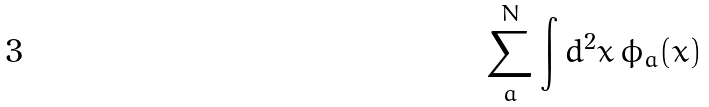Convert formula to latex. <formula><loc_0><loc_0><loc_500><loc_500>\sum _ { a } ^ { N } \int d ^ { 2 } x \, \phi _ { a } ( x )</formula> 